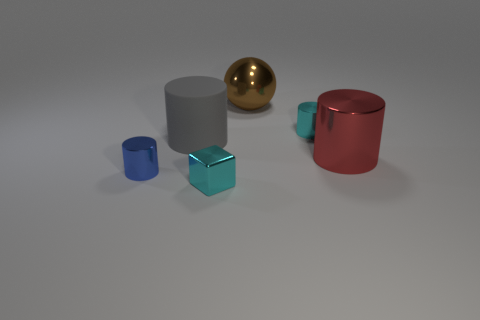Do the brown sphere and the gray cylinder have the same size?
Give a very brief answer. Yes. The red metallic thing that is the same size as the brown metal thing is what shape?
Provide a short and direct response. Cylinder. Is the size of the cyan metallic object on the right side of the cyan block the same as the metal ball?
Your response must be concise. No. There is a gray cylinder that is the same size as the shiny sphere; what is its material?
Your answer should be compact. Rubber. There is a tiny cyan shiny object that is behind the large cylinder that is in front of the matte thing; are there any shiny blocks that are behind it?
Keep it short and to the point. No. Is there any other thing that has the same shape as the gray object?
Offer a terse response. Yes. Does the small thing in front of the blue cylinder have the same color as the tiny metal object on the left side of the small block?
Make the answer very short. No. Are any blue metal cylinders visible?
Ensure brevity in your answer.  Yes. What material is the tiny object that is the same color as the tiny shiny block?
Your answer should be very brief. Metal. There is a cyan thing that is in front of the small cylinder that is to the left of the cyan thing in front of the gray matte cylinder; what is its size?
Make the answer very short. Small. 